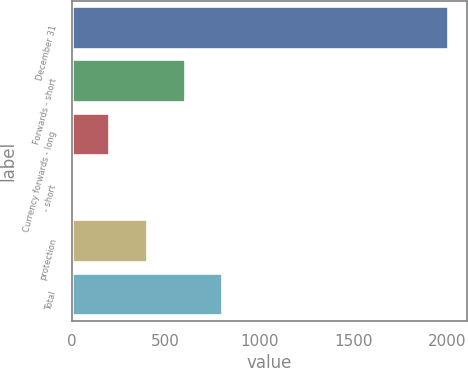Convert chart. <chart><loc_0><loc_0><loc_500><loc_500><bar_chart><fcel>December 31<fcel>Forwards - short<fcel>Currency forwards - long<fcel>- short<fcel>protection<fcel>Total<nl><fcel>2007<fcel>602.8<fcel>201.6<fcel>1<fcel>402.2<fcel>803.4<nl></chart> 